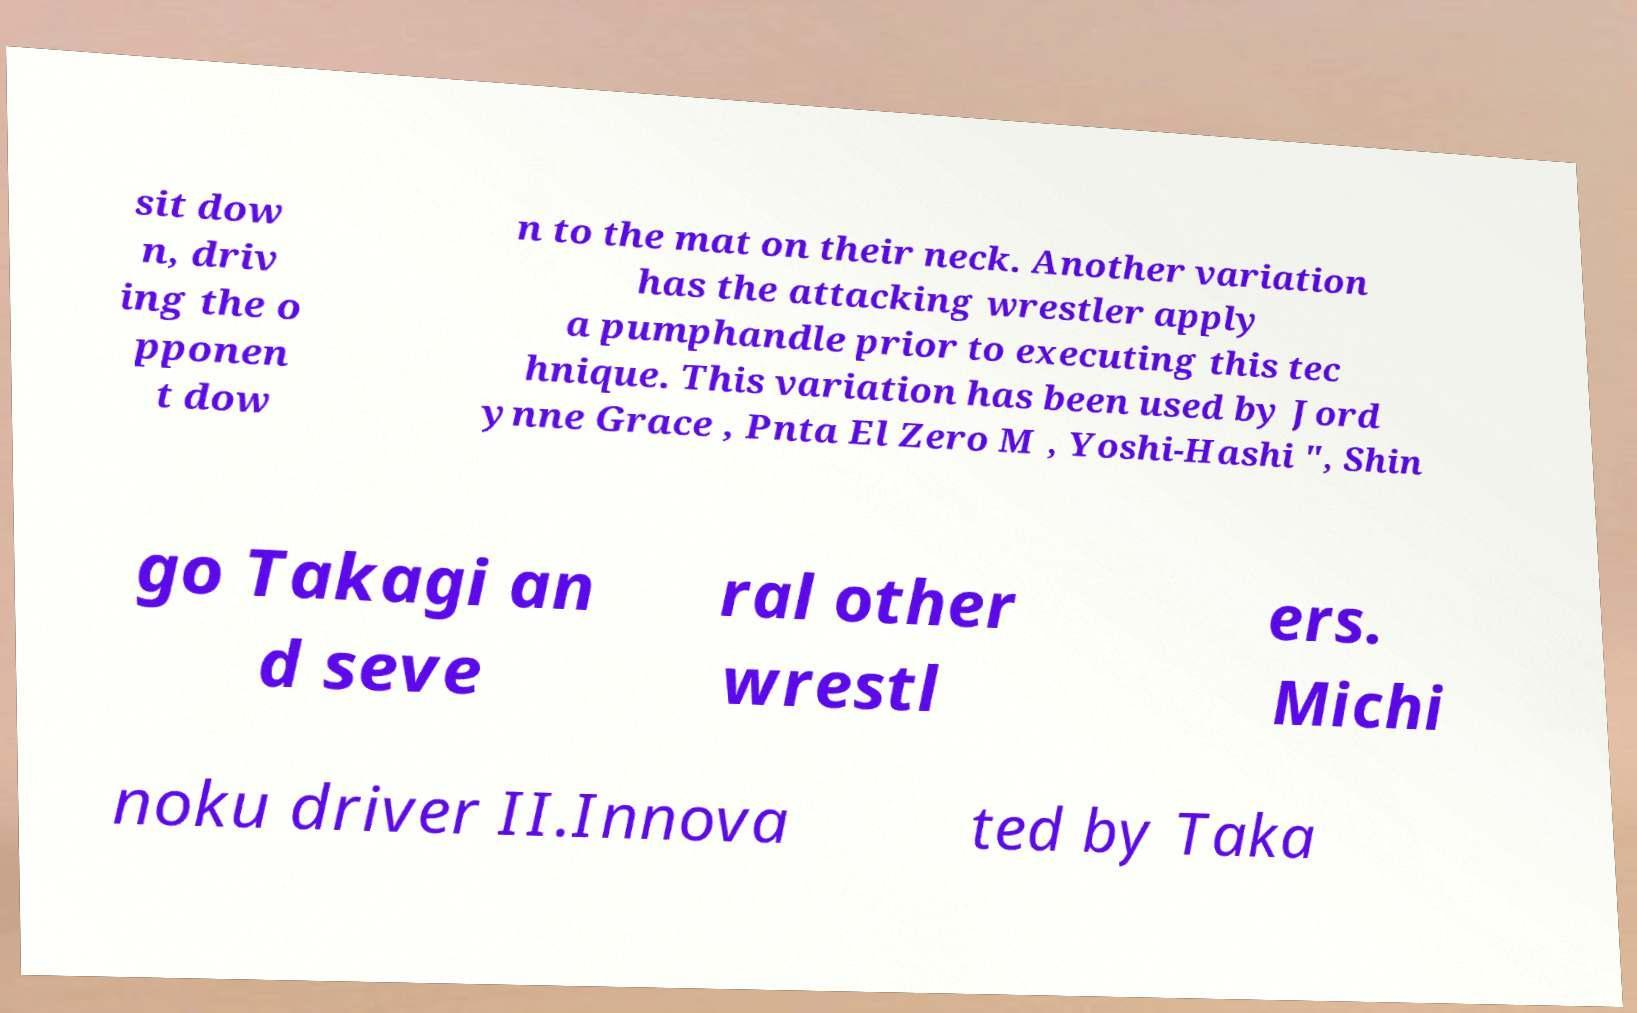Please identify and transcribe the text found in this image. sit dow n, driv ing the o pponen t dow n to the mat on their neck. Another variation has the attacking wrestler apply a pumphandle prior to executing this tec hnique. This variation has been used by Jord ynne Grace , Pnta El Zero M , Yoshi-Hashi ", Shin go Takagi an d seve ral other wrestl ers. Michi noku driver II.Innova ted by Taka 